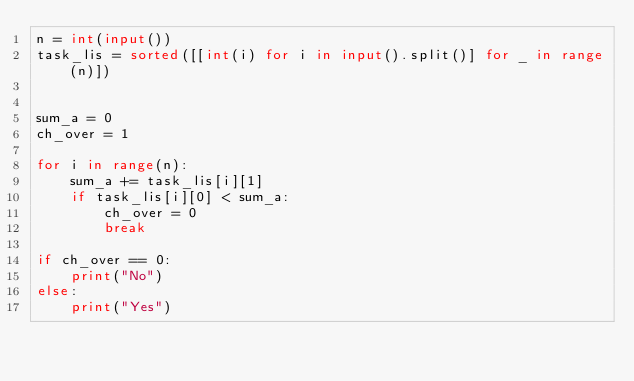Convert code to text. <code><loc_0><loc_0><loc_500><loc_500><_Python_>n = int(input())
task_lis = sorted([[int(i) for i in input().split()] for _ in range(n)])


sum_a = 0
ch_over = 1

for i in range(n):
    sum_a += task_lis[i][1]
    if task_lis[i][0] < sum_a:
        ch_over = 0
        break

if ch_over == 0:
    print("No")
else:
    print("Yes")
</code> 